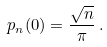Convert formula to latex. <formula><loc_0><loc_0><loc_500><loc_500>p _ { n } ( 0 ) = \frac { \sqrt { n } } { \pi } \, .</formula> 